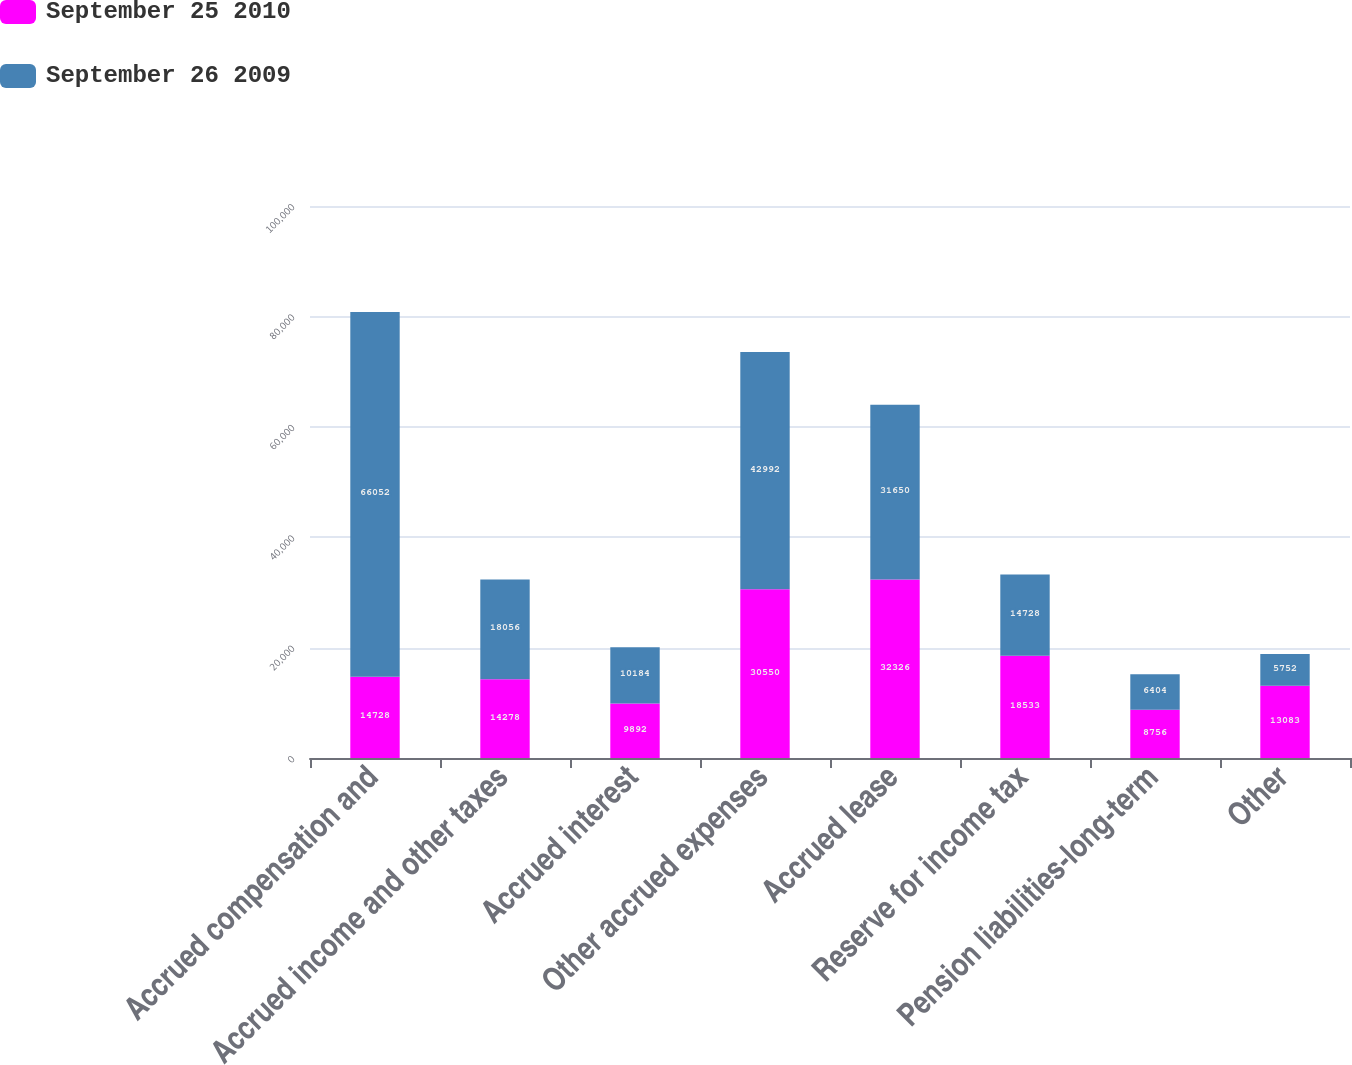Convert chart to OTSL. <chart><loc_0><loc_0><loc_500><loc_500><stacked_bar_chart><ecel><fcel>Accrued compensation and<fcel>Accrued income and other taxes<fcel>Accrued interest<fcel>Other accrued expenses<fcel>Accrued lease<fcel>Reserve for income tax<fcel>Pension liabilities-long-term<fcel>Other<nl><fcel>September 25 2010<fcel>14728<fcel>14278<fcel>9892<fcel>30550<fcel>32326<fcel>18533<fcel>8756<fcel>13083<nl><fcel>September 26 2009<fcel>66052<fcel>18056<fcel>10184<fcel>42992<fcel>31650<fcel>14728<fcel>6404<fcel>5752<nl></chart> 